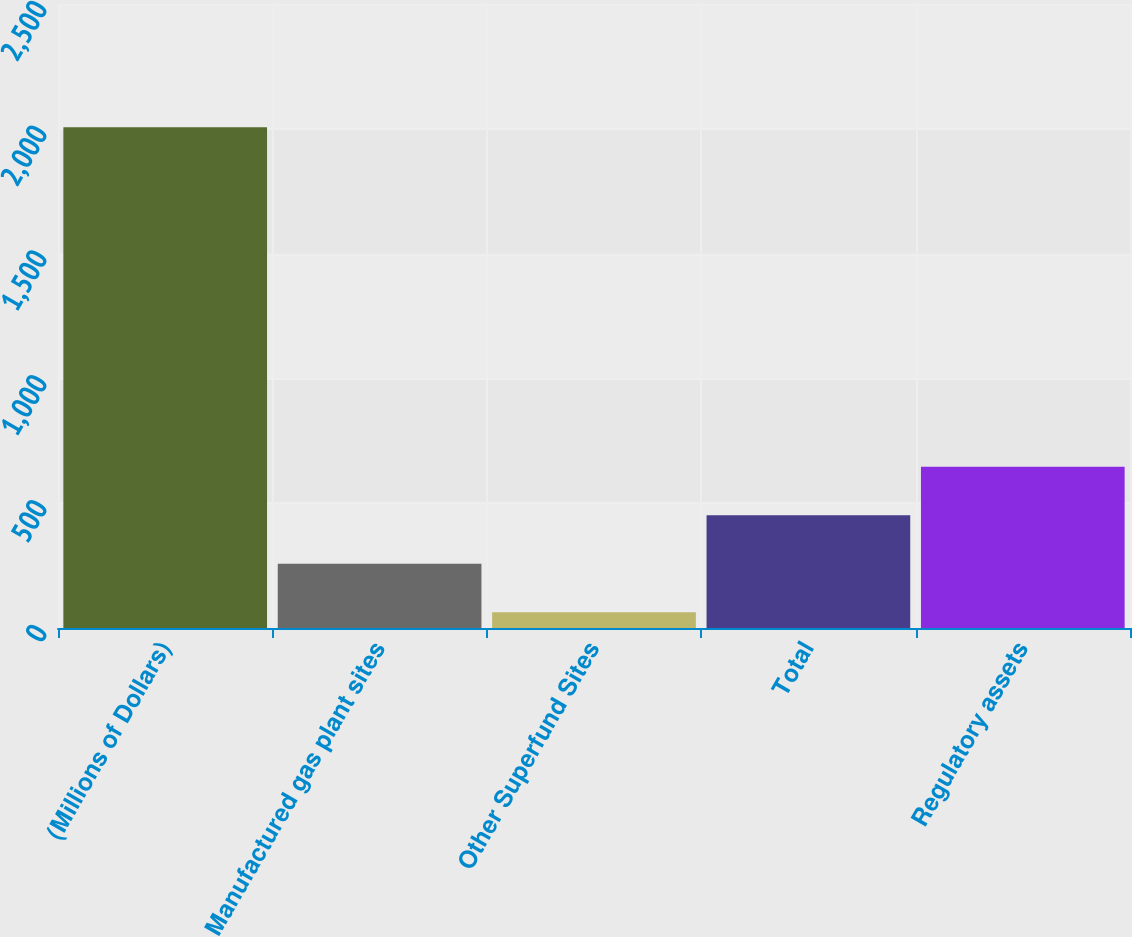<chart> <loc_0><loc_0><loc_500><loc_500><bar_chart><fcel>(Millions of Dollars)<fcel>Manufactured gas plant sites<fcel>Other Superfund Sites<fcel>Total<fcel>Regulatory assets<nl><fcel>2006<fcel>257.3<fcel>63<fcel>451.6<fcel>645.9<nl></chart> 